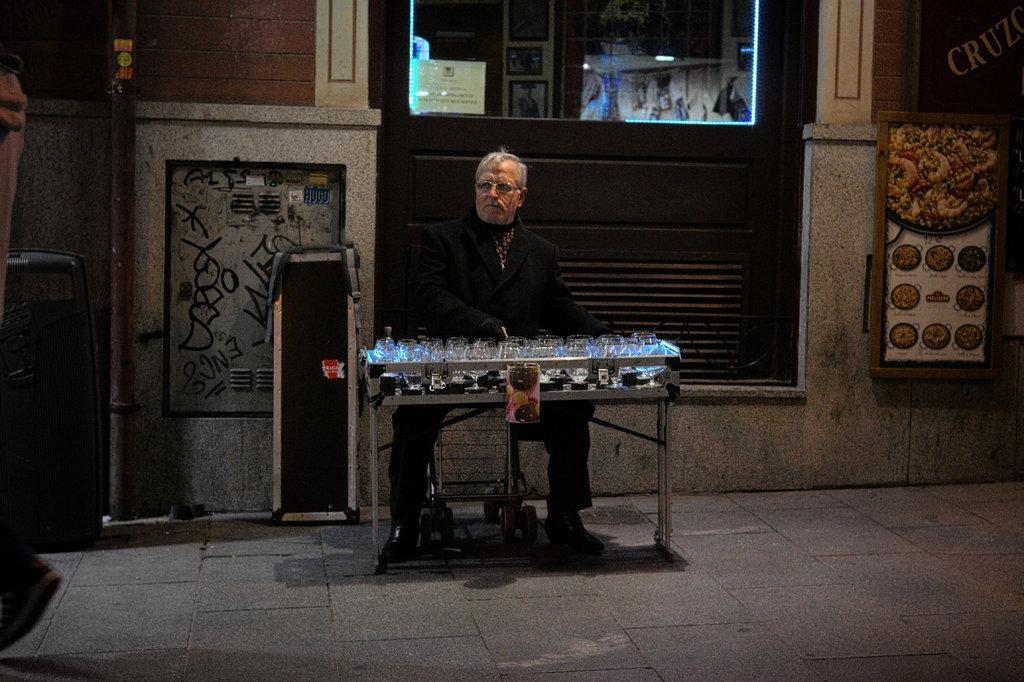In one or two sentences, can you explain what this image depicts? In this image there is a person sitting on a wheel chair, there is a table, there are glasses on the table, there are objects on the ground, there is a board, there is an object truncated towards the left of the image, at the background of the image there is the wall truncated, there is text on the wall, there is a pole truncated towards the top of the image, there is a paper on the glass, there is text on the paper, there is ground truncated towards the bottom of the image. 